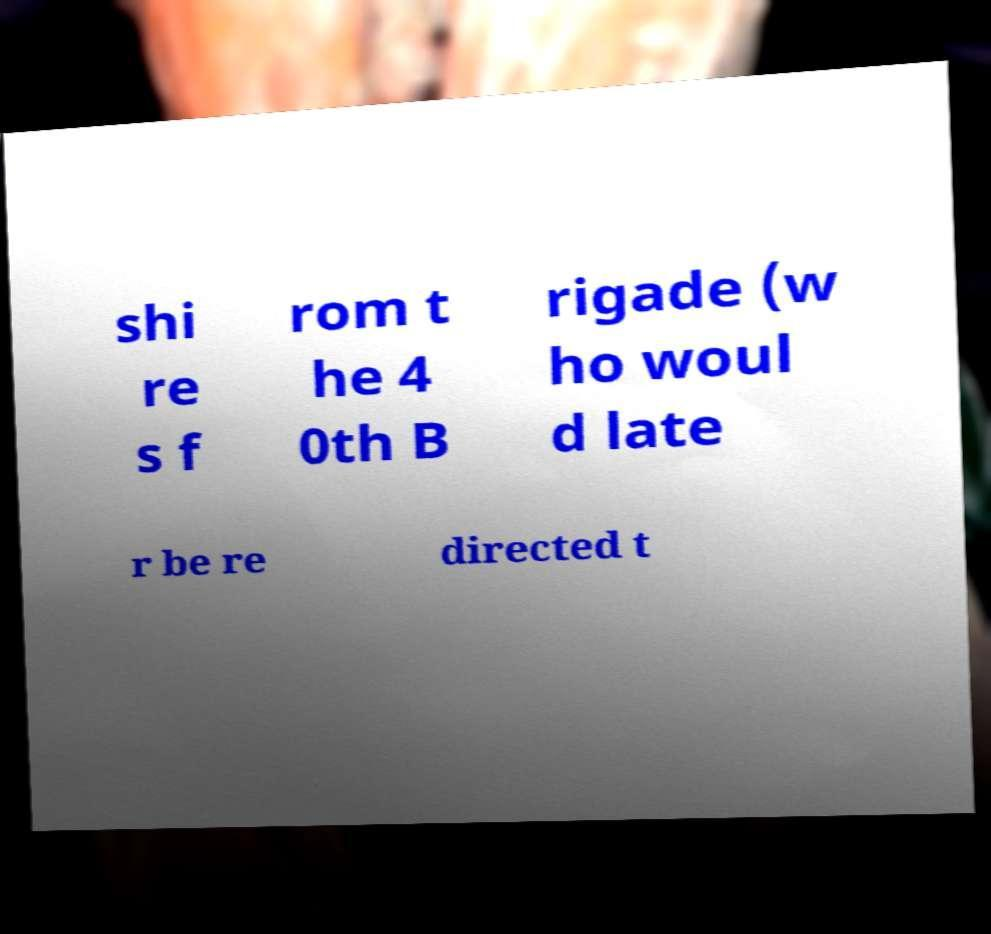Can you accurately transcribe the text from the provided image for me? shi re s f rom t he 4 0th B rigade (w ho woul d late r be re directed t 